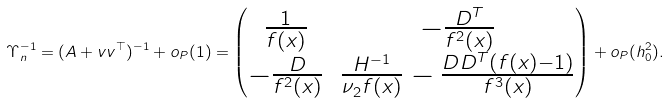Convert formula to latex. <formula><loc_0><loc_0><loc_500><loc_500>\Upsilon _ { n } ^ { - 1 } = ( A + v v ^ { \top } ) ^ { - 1 } + o _ { P } ( 1 ) = \begin{pmatrix} \frac { 1 } { f ( x ) } & - \frac { D ^ { T } } { f ^ { 2 } ( x ) } \\ - \frac { D } { f ^ { 2 } ( x ) } & \frac { H ^ { - 1 } } { \nu _ { 2 } f ( x ) } - \frac { D D ^ { T } ( f ( x ) - 1 ) } { f ^ { 3 } ( x ) } \end{pmatrix} + o _ { P } ( h _ { 0 } ^ { 2 } ) .</formula> 